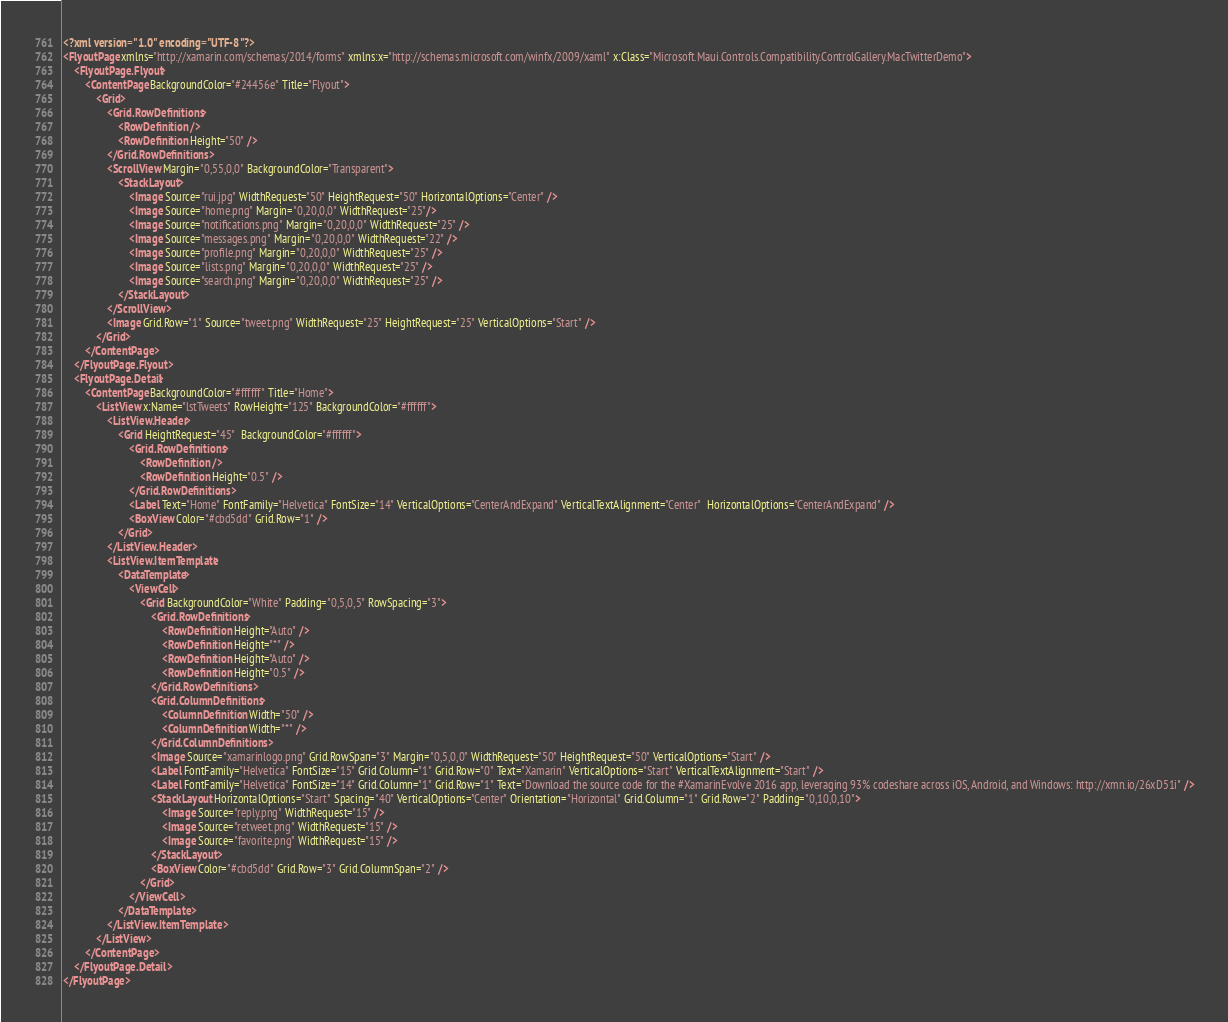Convert code to text. <code><loc_0><loc_0><loc_500><loc_500><_XML_><?xml version="1.0" encoding="UTF-8"?>
<FlyoutPage xmlns="http://xamarin.com/schemas/2014/forms" xmlns:x="http://schemas.microsoft.com/winfx/2009/xaml" x:Class="Microsoft.Maui.Controls.Compatibility.ControlGallery.MacTwitterDemo">
    <FlyoutPage.Flyout>
        <ContentPage BackgroundColor="#24456e" Title="Flyout">
            <Grid>
                <Grid.RowDefinitions>
                    <RowDefinition />
                    <RowDefinition Height="50" />
                </Grid.RowDefinitions>
                <ScrollView Margin="0,55,0,0" BackgroundColor="Transparent">
                    <StackLayout>
                        <Image Source="rui.jpg" WidthRequest="50" HeightRequest="50" HorizontalOptions="Center" />
                        <Image Source="home.png" Margin="0,20,0,0" WidthRequest="25"/>
                        <Image Source="notifications.png" Margin="0,20,0,0" WidthRequest="25" />
                        <Image Source="messages.png" Margin="0,20,0,0" WidthRequest="22" />
                        <Image Source="profile.png" Margin="0,20,0,0" WidthRequest="25" />
                        <Image Source="lists.png" Margin="0,20,0,0" WidthRequest="25" />
                        <Image Source="search.png" Margin="0,20,0,0" WidthRequest="25" />
                    </StackLayout>
                </ScrollView>
                <Image Grid.Row="1" Source="tweet.png" WidthRequest="25" HeightRequest="25" VerticalOptions="Start" />
            </Grid>
        </ContentPage>
    </FlyoutPage.Flyout>
    <FlyoutPage.Detail>
        <ContentPage BackgroundColor="#ffffff" Title="Home">
            <ListView x:Name="lstTweets" RowHeight="125" BackgroundColor="#ffffff">
                <ListView.Header>
                    <Grid HeightRequest="45"  BackgroundColor="#ffffff">
                        <Grid.RowDefinitions>
                            <RowDefinition />
                            <RowDefinition Height="0.5" />
                        </Grid.RowDefinitions>
                        <Label Text="Home" FontFamily="Helvetica" FontSize="14" VerticalOptions="CenterAndExpand" VerticalTextAlignment="Center"  HorizontalOptions="CenterAndExpand" />
                        <BoxView Color="#cbd5dd" Grid.Row="1" />
                    </Grid>
                </ListView.Header>
                <ListView.ItemTemplate>
                    <DataTemplate>
                        <ViewCell>
                            <Grid BackgroundColor="White" Padding="0,5,0,5" RowSpacing="3">
                                <Grid.RowDefinitions>
                                    <RowDefinition Height="Auto" />
                                    <RowDefinition Height="*" />
                                    <RowDefinition Height="Auto" />
                                    <RowDefinition Height="0.5" />
                                </Grid.RowDefinitions>
                                <Grid.ColumnDefinitions>
                                    <ColumnDefinition Width="50" />
                                    <ColumnDefinition Width="*" />
                                </Grid.ColumnDefinitions>
                                <Image Source="xamarinlogo.png" Grid.RowSpan="3" Margin="0,5,0,0" WidthRequest="50" HeightRequest="50" VerticalOptions="Start" />
                                <Label FontFamily="Helvetica" FontSize="15" Grid.Column="1" Grid.Row="0" Text="Xamarin" VerticalOptions="Start" VerticalTextAlignment="Start" />
                                <Label FontFamily="Helvetica" FontSize="14" Grid.Column="1" Grid.Row="1" Text="Download the source code for the #XamarinEvolve 2016 app, leveraging 93% codeshare across iOS, Android, and Windows: http://xmn.io/26xD51i" />
                                <StackLayout HorizontalOptions="Start" Spacing="40" VerticalOptions="Center" Orientation="Horizontal" Grid.Column="1" Grid.Row="2" Padding="0,10,0,10">
                                    <Image Source="reply.png" WidthRequest="15" />
                                    <Image Source="retweet.png" WidthRequest="15" />
                                    <Image Source="favorite.png" WidthRequest="15" />
                                </StackLayout>
                                <BoxView Color="#cbd5dd" Grid.Row="3" Grid.ColumnSpan="2" />
                            </Grid>
                        </ViewCell>
                    </DataTemplate>
                </ListView.ItemTemplate>
            </ListView>
        </ContentPage>
    </FlyoutPage.Detail>
</FlyoutPage></code> 